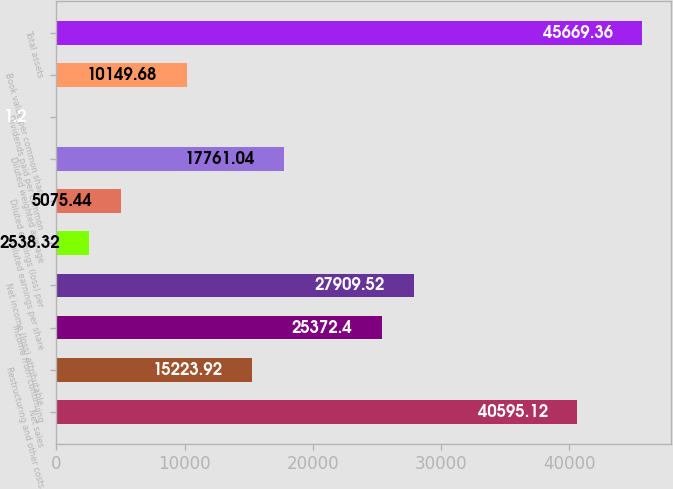<chart> <loc_0><loc_0><loc_500><loc_500><bar_chart><fcel>Net sales<fcel>Restructuring and other costs<fcel>Income from continuing<fcel>Net income (loss) attributable<fcel>Diluted earnings per share<fcel>Diluted earnings (loss) per<fcel>Diluted weighted average<fcel>Dividends paid per common<fcel>Book value per common share<fcel>Total assets<nl><fcel>40595.1<fcel>15223.9<fcel>25372.4<fcel>27909.5<fcel>2538.32<fcel>5075.44<fcel>17761<fcel>1.2<fcel>10149.7<fcel>45669.4<nl></chart> 